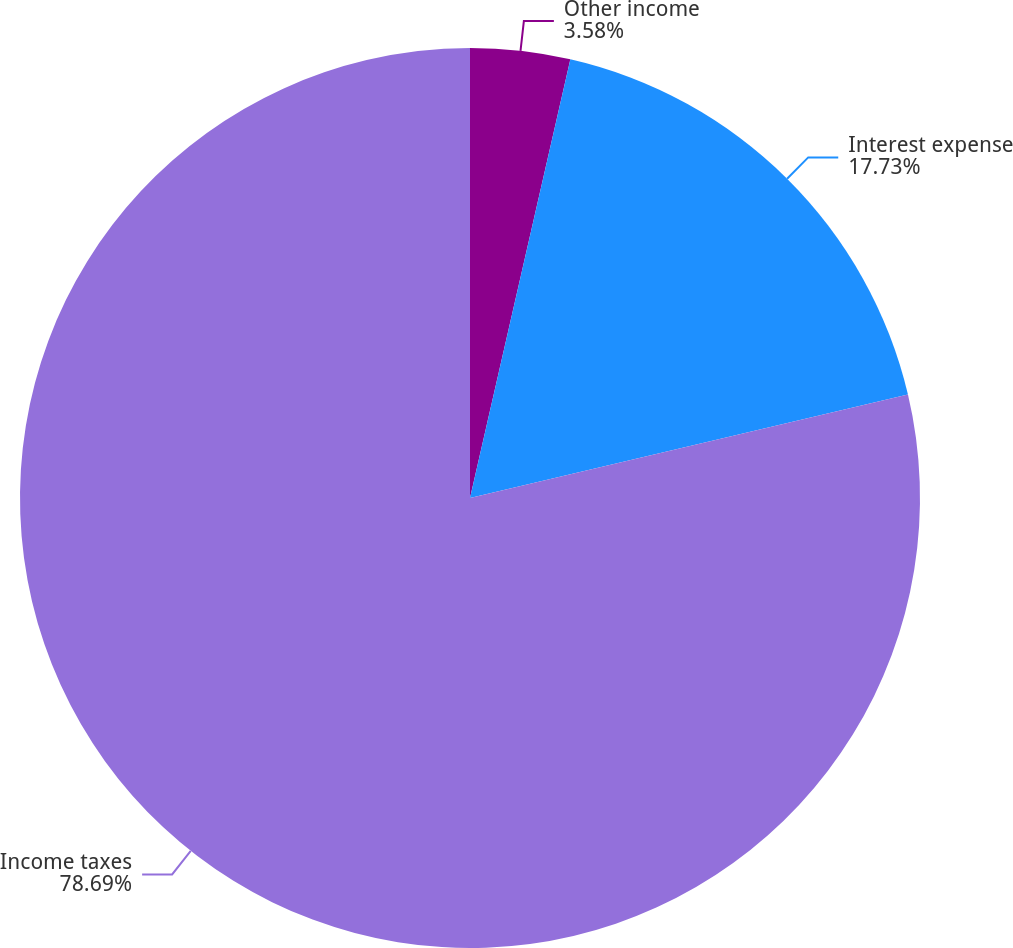Convert chart to OTSL. <chart><loc_0><loc_0><loc_500><loc_500><pie_chart><fcel>Other income<fcel>Interest expense<fcel>Income taxes<nl><fcel>3.58%<fcel>17.73%<fcel>78.69%<nl></chart> 